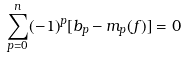<formula> <loc_0><loc_0><loc_500><loc_500>\sum _ { p = 0 } ^ { n } ( - 1 ) ^ { p } [ b _ { p } - m _ { p } ( f ) ] = 0</formula> 